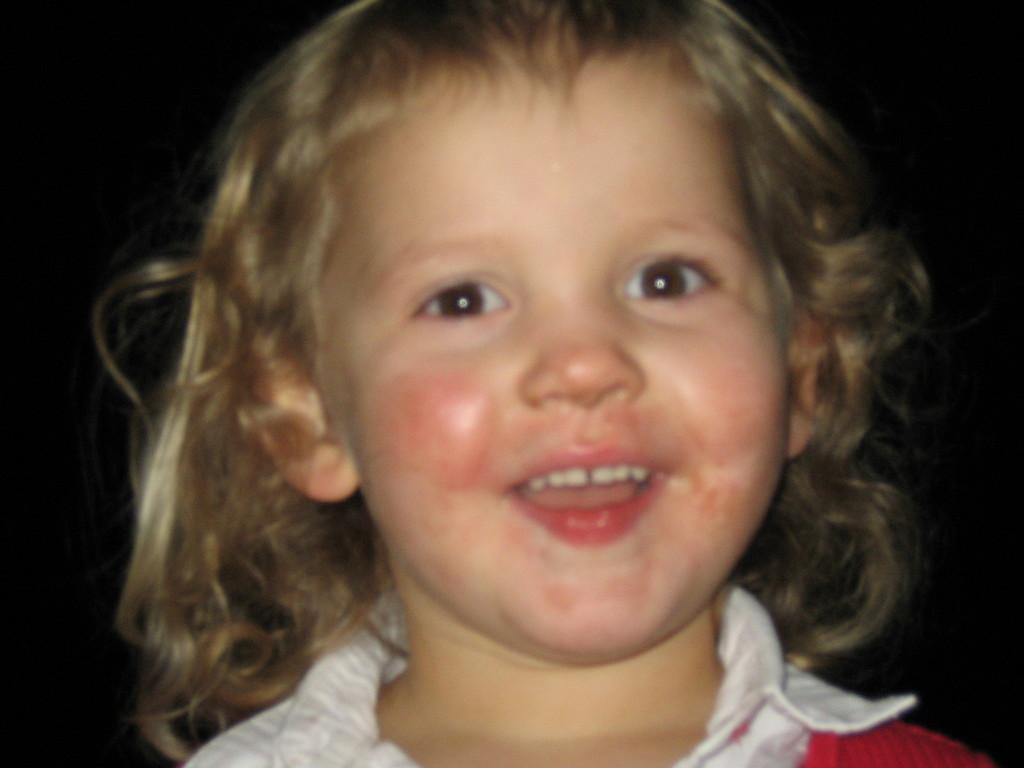What is the main subject of the image? The main subject of the image is a kid. What is the kid's facial expression in the image? The kid is smiling in the image. What type of underwear is the kid wearing in the image? There is no information about the kid's underwear in the image, so it cannot be determined. 